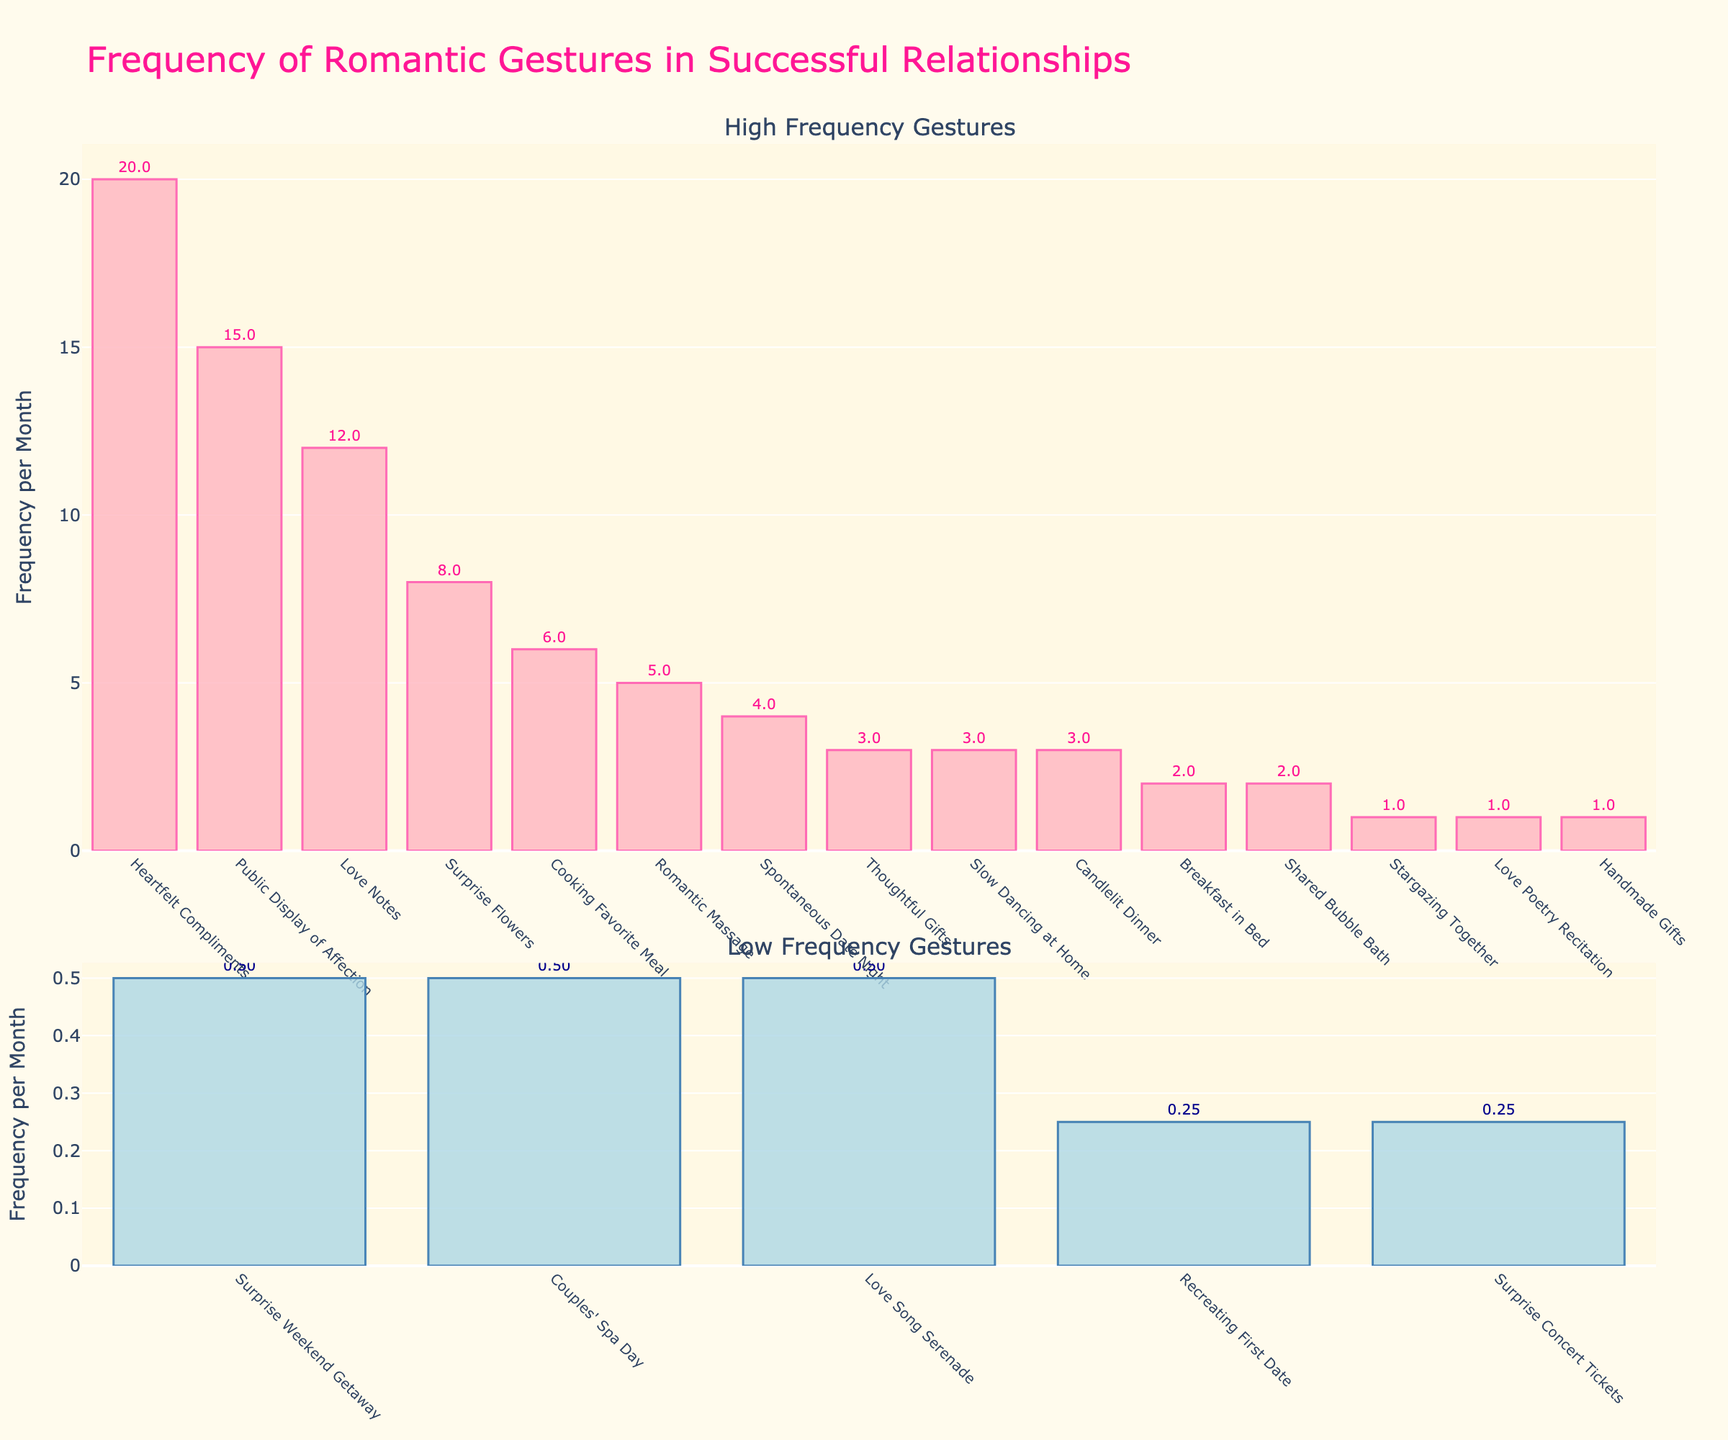Which romantic gesture has the highest frequency per month? Look at the height of the bars in the first plot. The gesture with the tallest bar represents the highest frequency. "Heartfelt Compliments" has the highest bar.
Answer: Heartfelt Compliments What is the combined frequency of "Surprise Flowers" and "Love Notes"? Find the frequencies of each gesture from the first plot and sum them together. "Surprise Flowers" has a frequency of 8, and "Love Notes" has a frequency of 12. Adding these together, 8 + 12.
Answer: 20 Which gesture has a higher frequency: "Public Display of Affection" or "Cooking Favorite Meal"? Compare the heights of the bars for "Public Display of Affection" and "Cooking Favorite Meal". "Public Display of Affection" is taller.
Answer: Public Display of Affection What is the total frequency of the gestures with a frequency less than 1? Refer to the second plot for gestures with frequencies less than 1. Sum all their frequencies: 0.5 + 0.25 + 0.5 + 0.25 + 0.5.
Answer: 2 Among the low-frequency gestures, which one occurs least frequently? Look at the bars in the second plot and find the shortest one which represents the lowest frequency. "Recreating First Date" has the shortest bar.
Answer: Recreating First Date What is the difference in frequency between "Thoughtful Gifts" and "Candlelit Dinner"? Note the frequencies of both gestures from the first plot. "Thoughtful Gifts" has a frequency of 3, and "Candlelit Dinner" also has a frequency of 3. Calculate the difference: 3 - 3.
Answer: 0 Which romantic gesture is highlighted in blue? Look for bars that are colored blue in both plots. All bars in the second plot (low-frequency gestures) are highlighted in blue.
Answer: Low frequency gestures What visual attributes distinguish high-frequency gestures from low-frequency gestures? Observe the colors and heights of the bars in both plots. High-frequency gestures are in pink, and low-frequency gestures are in blue. High-frequency gestures are taller overall.
Answer: Color and height What is the average frequency of gestures in the high-frequency category? Find the total frequency of all high-frequency gestures and divide by the number of those gestures. Sum the frequencies of all high-frequency gestures: 8 + 12 + 6 + 4 + 20 + 3 + 5 + 3 + 2 + 3 + 15. Calculate the sum: 81. Divide by the number of gestures: 11.
Answer: 7.36 